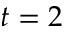<formula> <loc_0><loc_0><loc_500><loc_500>t = 2</formula> 